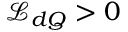Convert formula to latex. <formula><loc_0><loc_0><loc_500><loc_500>\mathcal { L } _ { d Q } > 0</formula> 